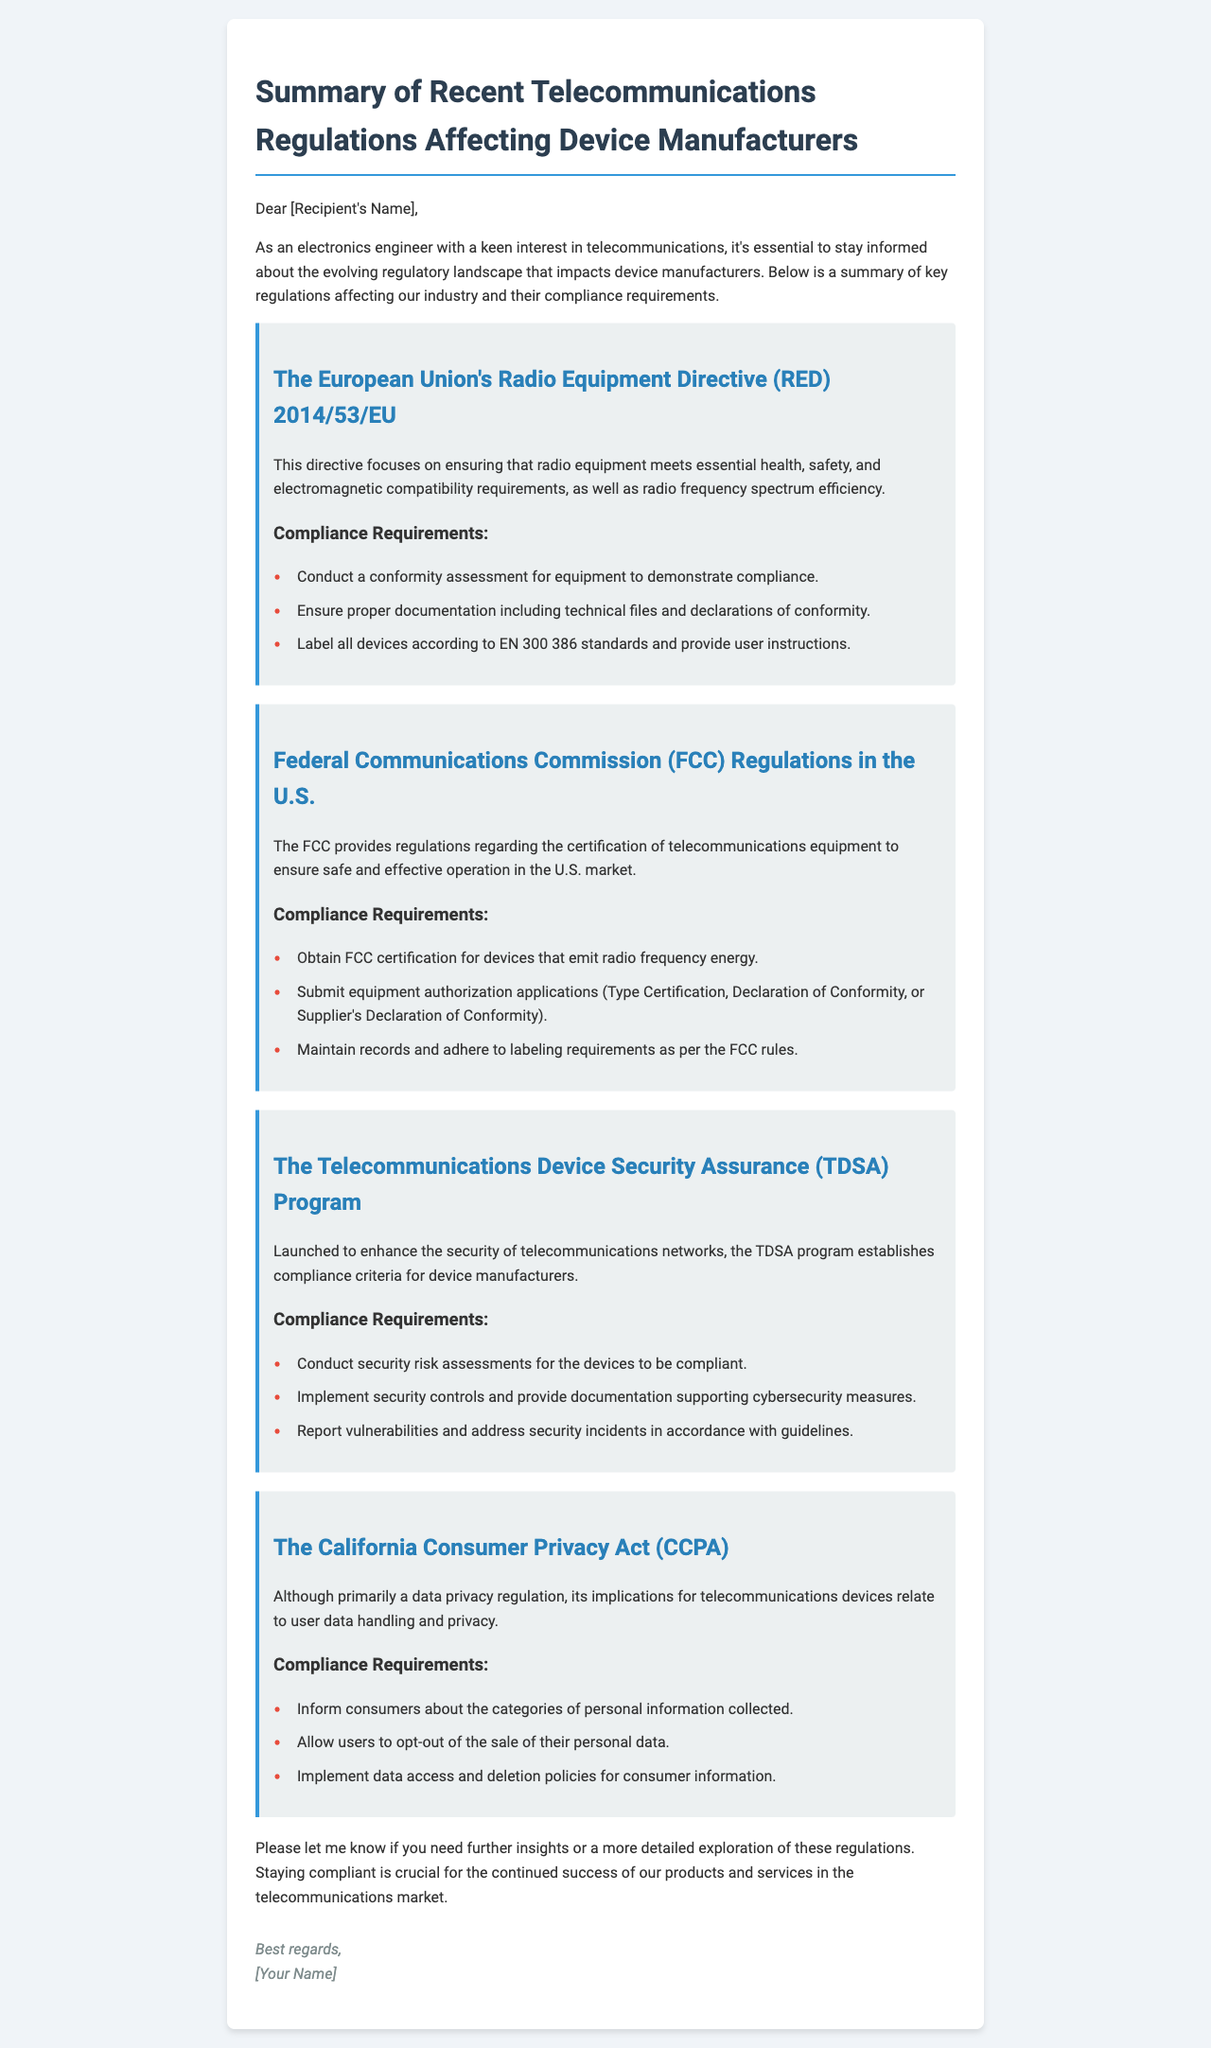What is the title of the document? The title of the document is indicated at the top of the email summary in a bold format.
Answer: Summary of Recent Telecommunications Regulations Affecting Device Manufacturers What directive is mentioned in the EU regulations section? The directive discussed within the EU regulations section is specifically highlighted by its designated number.
Answer: Radio Equipment Directive (RED) 2014/53/EU How many key compliance requirements are listed under the FCC regulations? The number of compliance requirements mentioned under the FCC regulations is stated clearly in the section.
Answer: Three What does TDSA stand for? TDSA is an acronym used in the document, elucidated in the introduction of the relevant regulation.
Answer: Telecommunications Device Security Assurance What are device manufacturers required to implement according to the TDSA program? The implementation requirement is a crucial compliance aspect mentioned in the TDSA compliance section.
Answer: Security controls What act does the CCPA relate to? The acronym CCPA in the document stands for a specific act that governs consumer privacy.
Answer: California Consumer Privacy Act What must consumers be informed about under the CCPA? The specific information regarding consumer data that companies are required to disclose is noted in the compliance requirements.
Answer: Categories of personal information collected How does the summary email conclude? The conclusion of the email provides closure and offers the recipient further assistance.
Answer: Further insights or detailed exploration of regulations 